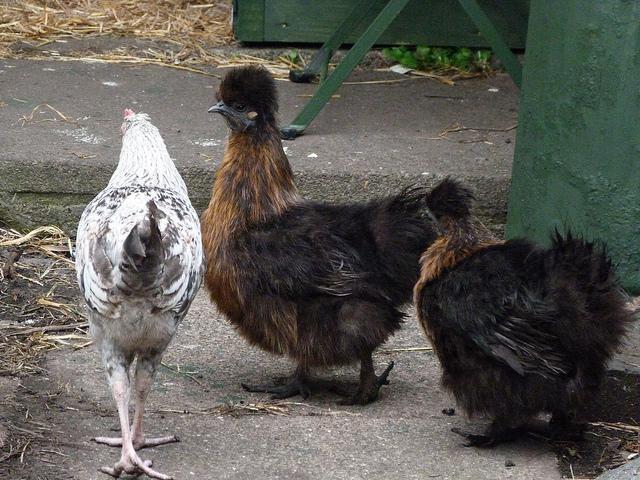How many birds?
Give a very brief answer. 3. How many birds are the same color?
Give a very brief answer. 2. How many birds are there?
Give a very brief answer. 3. 